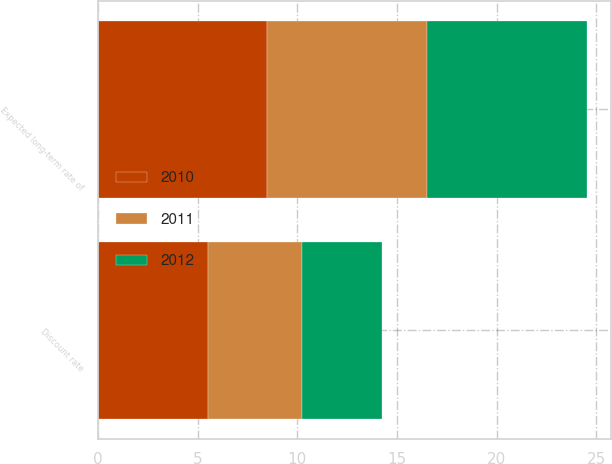Convert chart. <chart><loc_0><loc_0><loc_500><loc_500><stacked_bar_chart><ecel><fcel>Discount rate<fcel>Expected long-term rate of<nl><fcel>2012<fcel>4<fcel>8<nl><fcel>2011<fcel>4.75<fcel>8<nl><fcel>2010<fcel>5.5<fcel>8.5<nl></chart> 